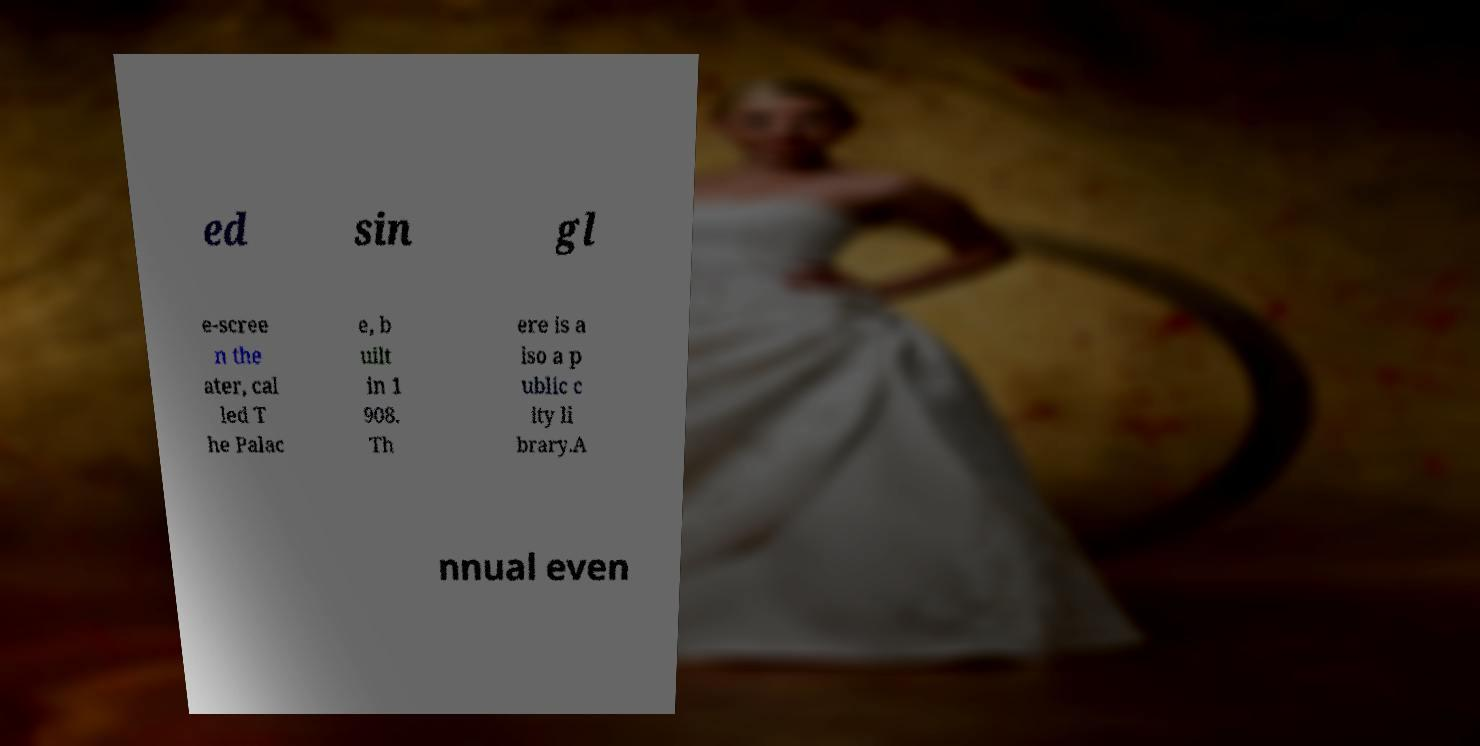Please identify and transcribe the text found in this image. ed sin gl e-scree n the ater, cal led T he Palac e, b uilt in 1 908. Th ere is a lso a p ublic c ity li brary.A nnual even 